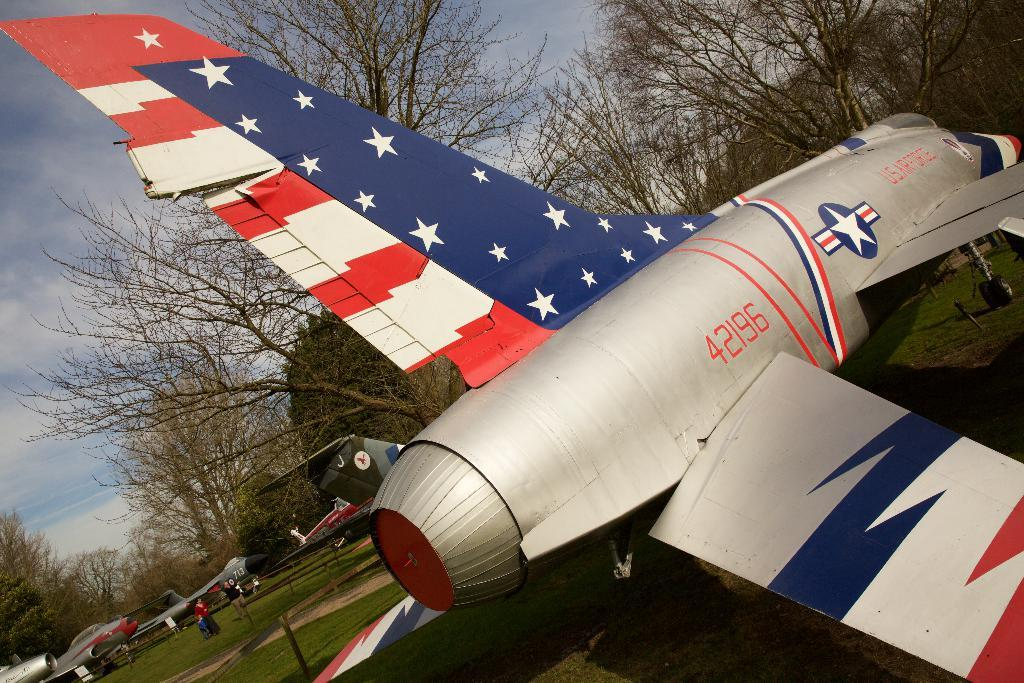<image>
Relay a brief, clear account of the picture shown. A patriotic US Air Force jet has a stars and stripes design on the tail and the number 42196 over its wing.. 